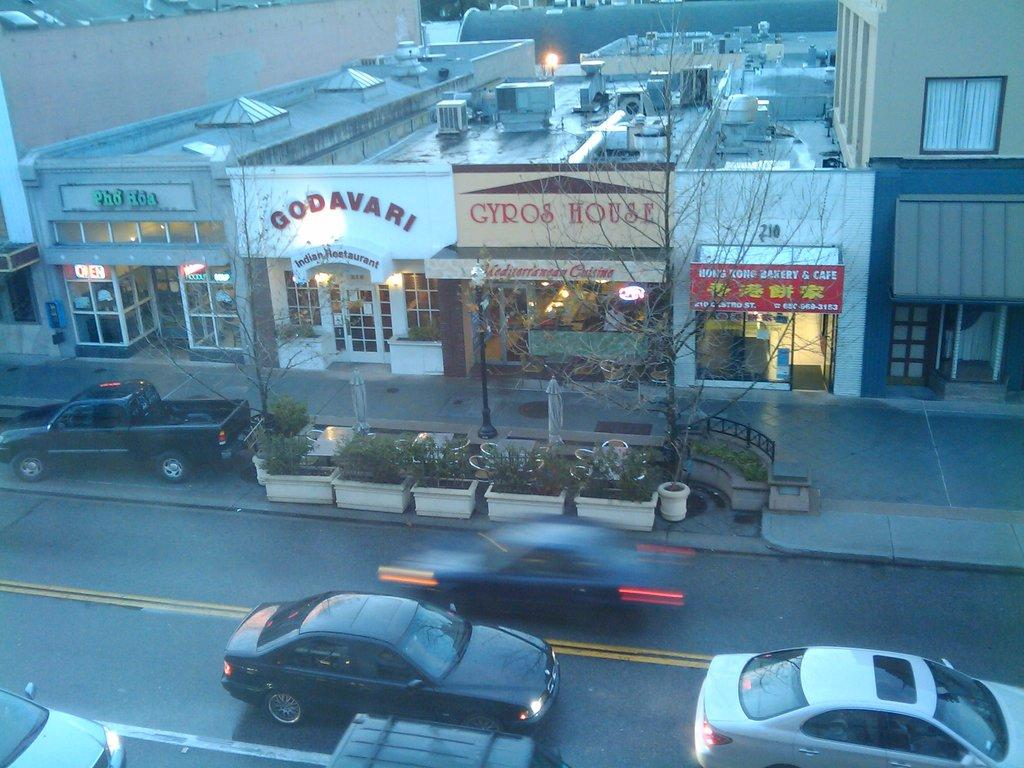What type of structures can be seen in the image? There are buildings in the image. What natural elements are present in the image? There are trees and plants in the image. What is the tall, vertical object in the image? There is a pole in the image. What type of transportation is visible on the road at the bottom of the image? There are cars on the road at the bottom of the image. What are the flat, rectangular objects in the image? There are boards visible in the image. What type of war is being fought in the image? There is no war present in the image; it features buildings, trees, a pole, plants, cars, and boards. How many trees are shown biting each other in the image? There is no tree biting each other in the image; trees are present but not interacting with each other. 